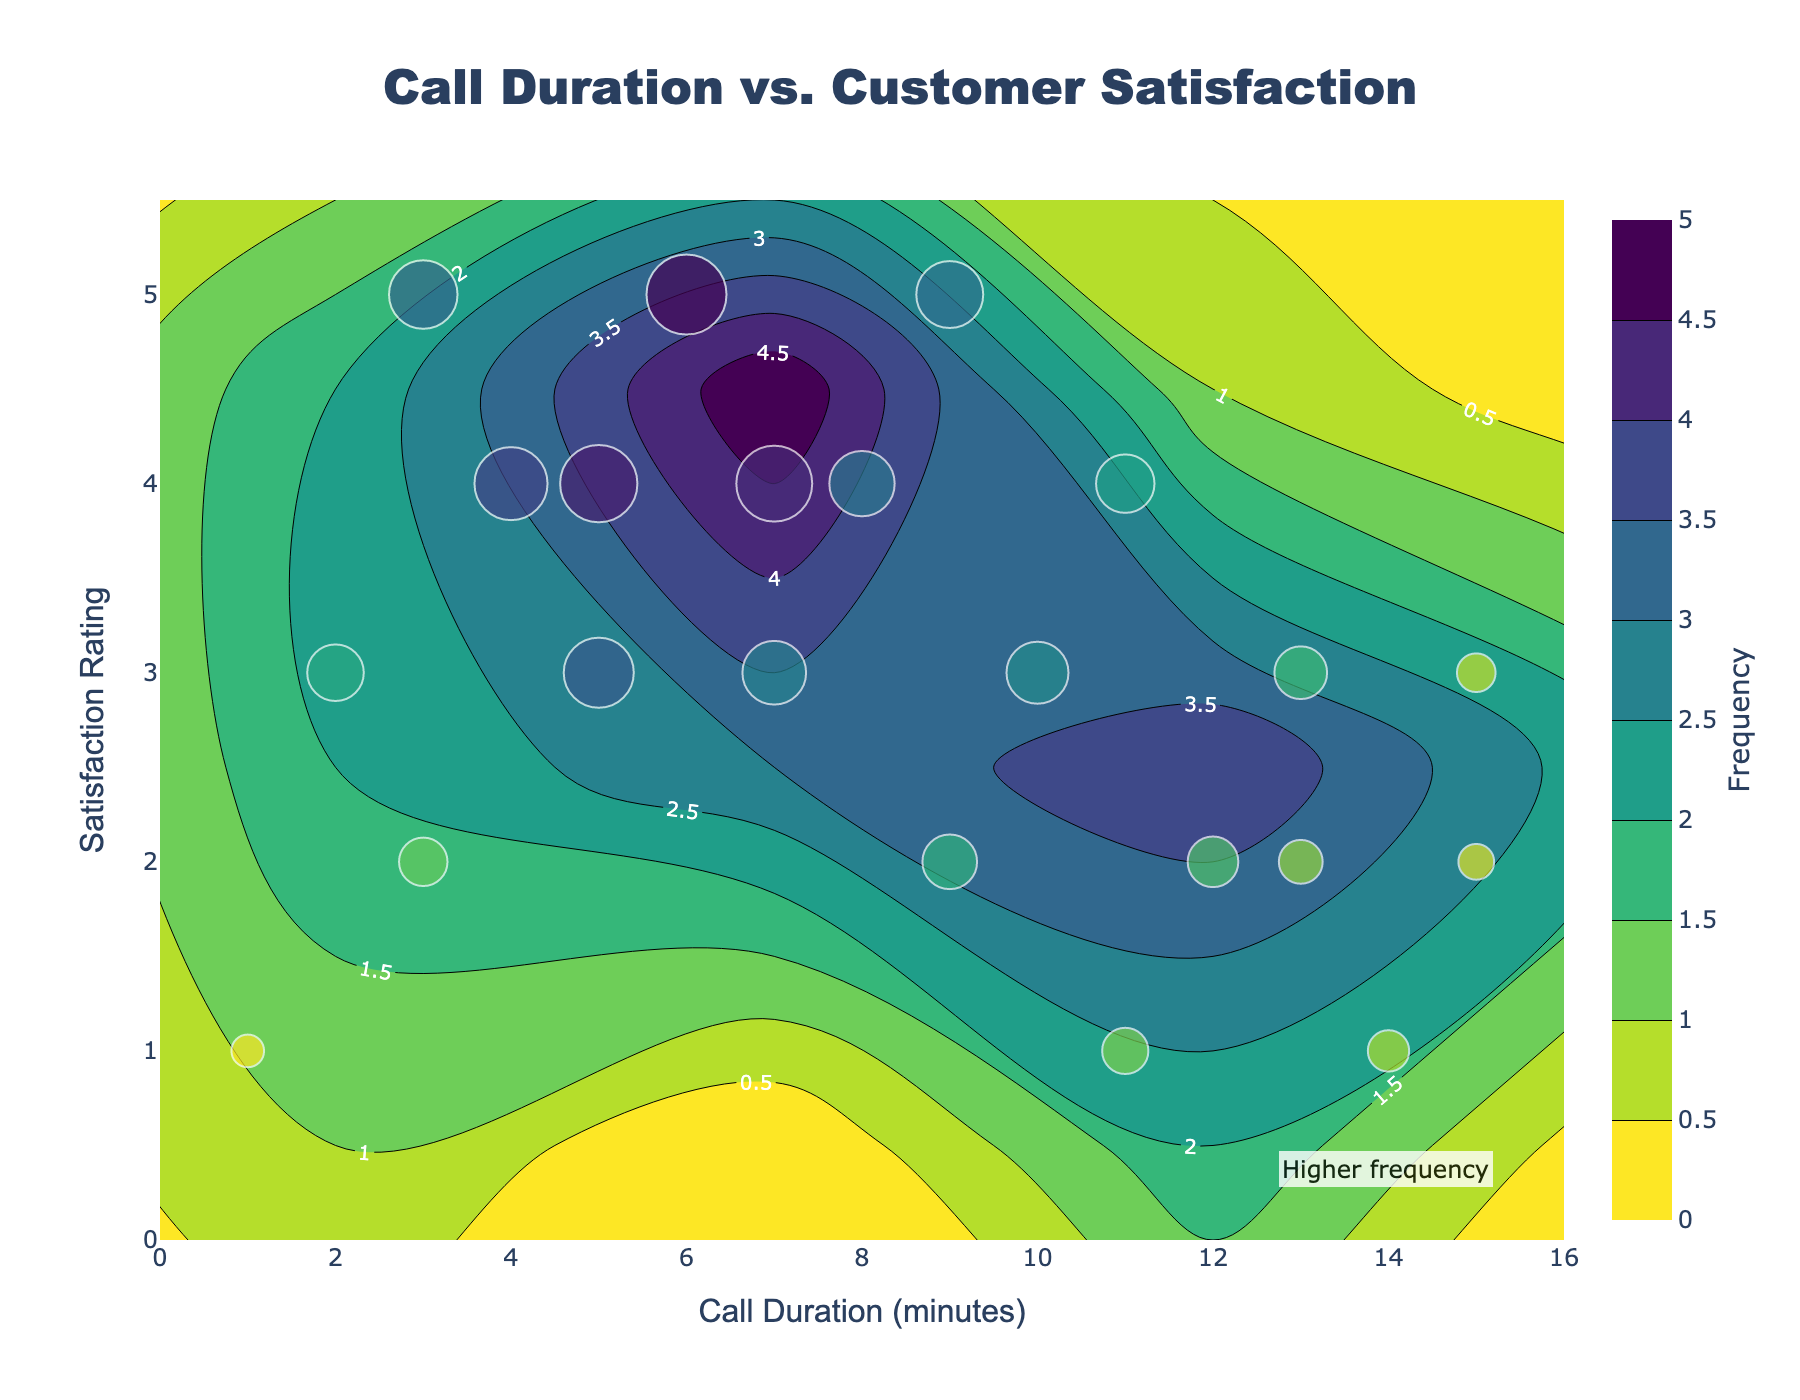What is the title of the plot? The title of the plot is written at the top and it reads 'Call Duration vs. Customer Satisfaction'.
Answer: Call Duration vs. Customer Satisfaction What are the axes labeled with? The x-axis is labeled 'Call Duration (minutes)' and the y-axis is labeled 'Satisfaction Rating'. These labels are positioned at the bottom and left side of the axes, respectively.
Answer: Call Duration (minutes) and Satisfaction Rating How many satisfaction rating levels are shown in the plot? The y-axis shows satisfaction ratings from 1 to 5, totalling 5 different levels. This can be quickly identified by counting the tick marks or labels on the y-axis.
Answer: 5 Which call duration has the highest overall frequency? By observing the size of the scatter plot points and the contour colors, the call duration of 6 minutes has the highest frequency, indicated by the largest bubble and most intense color.
Answer: 6 minutes How does satisfaction rating of 5 vary with call duration? Satisfaction rating of 5 occurs at call durations of 6 minutes and 9 minutes. The frequency is higher at 6 minutes compared to 9 minutes, deduced from the larger size of the scatter points at these durations.
Answer: Higher at 6 minutes What is the trend between call duration and satisfaction rating? Generally, as the call duration increases, the satisfaction rating tends to decrease, with a notable concentration of lower satisfaction ratings at longer call durations. This can be seen by the scatter point distribution and contour levels.
Answer: Satisfaction decreases with longer call durations Which call duration and satisfaction rating combination has the lowest frequency? By looking at the smallest scatter points and their associated color scales, the combination of 15 minutes call duration and 2 satisfaction rating has the lowest frequency.
Answer: 15 minutes and 2 How do the frequencies of satisfaction ratings at call duration of 7 minutes compare? At a call duration of 7 minutes, satisfaction ratings of 4 have the highest frequency followed by ratings of 3 and 5 respectively, as indicated by the size of the scatter points and contour intensity.
Answer: Highest for rating 4, then 3, and 5 What's the average frequency for a call duration of 11 minutes? Frequencies for 11 minutes call duration are associated with satisfaction ratings of 1 and 4 having frequencies of 10 and 16 respectively. Thus, the average frequency is (10 + 16) / 2 = 13.
Answer: 13 Which call durations appear to have the broadest range of satisfaction ratings? Call durations of 5 and 7 minutes cover a wide range of satisfaction ratings from 2 to 5, identified by the presence of scatter points across these rating levels.
Answer: 5 and 7 minutes 